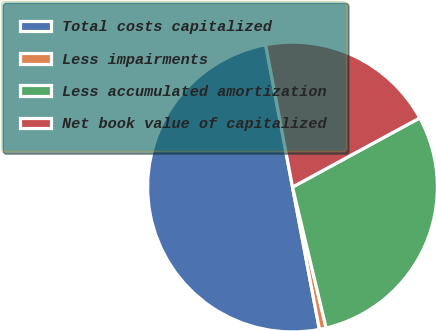Convert chart to OTSL. <chart><loc_0><loc_0><loc_500><loc_500><pie_chart><fcel>Total costs capitalized<fcel>Less impairments<fcel>Less accumulated amortization<fcel>Net book value of capitalized<nl><fcel>50.0%<fcel>0.76%<fcel>29.19%<fcel>20.05%<nl></chart> 